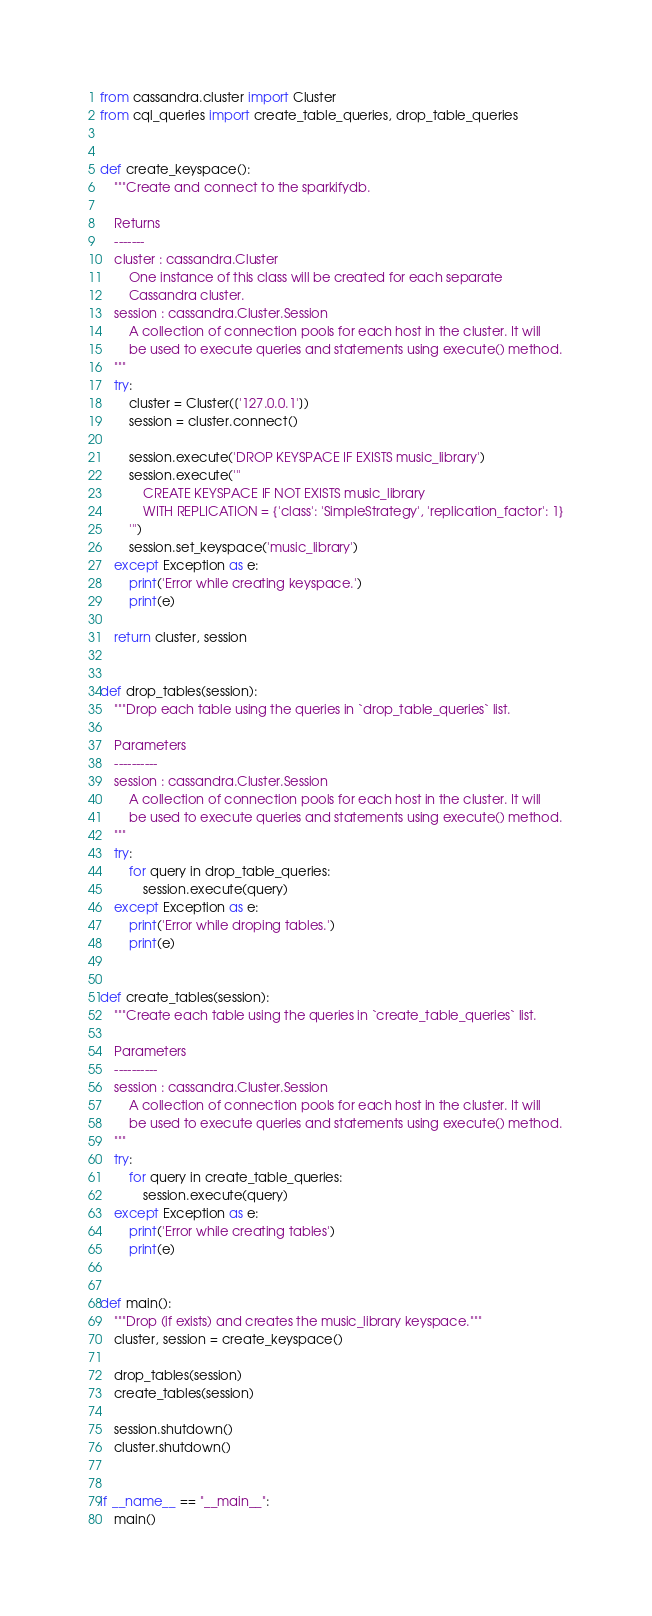<code> <loc_0><loc_0><loc_500><loc_500><_Python_>from cassandra.cluster import Cluster
from cql_queries import create_table_queries, drop_table_queries


def create_keyspace():
    """Create and connect to the sparkifydb.

    Returns
    -------
    cluster : cassandra.Cluster
        One instance of this class will be created for each separate 
        Cassandra cluster.
    session : cassandra.Cluster.Session
        A collection of connection pools for each host in the cluster. It will
        be used to execute queries and statements using execute() method.
    """
    try:
        cluster = Cluster(['127.0.0.1'])
        session = cluster.connect()

        session.execute('DROP KEYSPACE IF EXISTS music_library')
        session.execute('''
            CREATE KEYSPACE IF NOT EXISTS music_library
            WITH REPLICATION = {'class': 'SimpleStrategy', 'replication_factor': 1}
        ''')
        session.set_keyspace('music_library')
    except Exception as e:
        print('Error while creating keyspace.')
        print(e)

    return cluster, session


def drop_tables(session):
    """Drop each table using the queries in `drop_table_queries` list.

    Parameters
    ----------
    session : cassandra.Cluster.Session
        A collection of connection pools for each host in the cluster. It will
        be used to execute queries and statements using execute() method.
    """
    try:
        for query in drop_table_queries:
            session.execute(query)
    except Exception as e:
        print('Error while droping tables.')
        print(e)


def create_tables(session):
    """Create each table using the queries in `create_table_queries` list. 

    Parameters
    ----------
    session : cassandra.Cluster.Session
        A collection of connection pools for each host in the cluster. It will
        be used to execute queries and statements using execute() method.
    """
    try:
        for query in create_table_queries:
            session.execute(query)
    except Exception as e:
        print('Error while creating tables')
        print(e)


def main():
    """Drop (if exists) and creates the music_library keyspace."""
    cluster, session = create_keyspace()

    drop_tables(session)
    create_tables(session)

    session.shutdown()
    cluster.shutdown()


if __name__ == "__main__":
    main()
</code> 